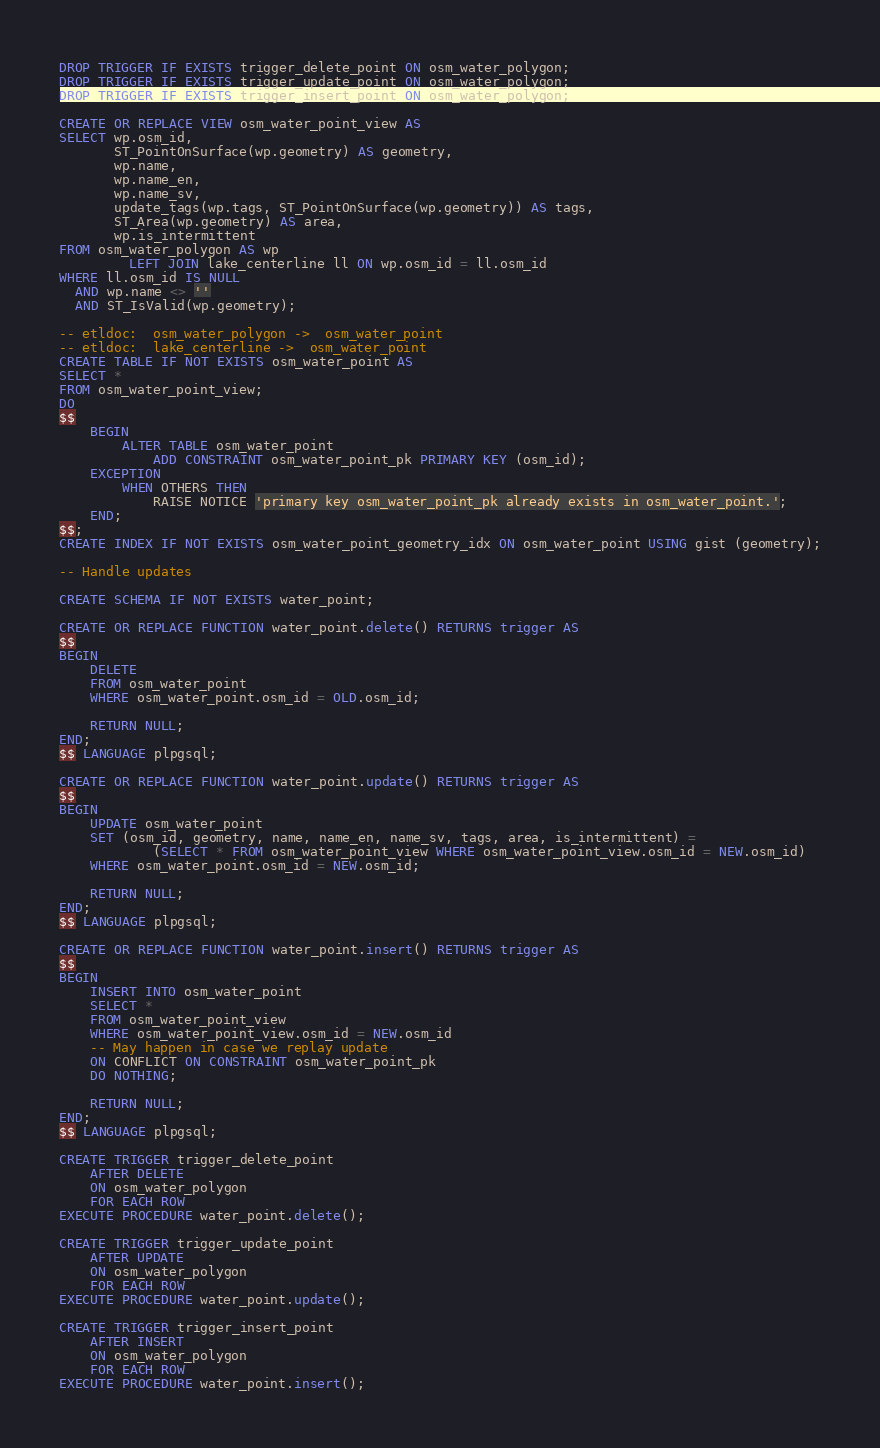<code> <loc_0><loc_0><loc_500><loc_500><_SQL_>DROP TRIGGER IF EXISTS trigger_delete_point ON osm_water_polygon;
DROP TRIGGER IF EXISTS trigger_update_point ON osm_water_polygon;
DROP TRIGGER IF EXISTS trigger_insert_point ON osm_water_polygon;

CREATE OR REPLACE VIEW osm_water_point_view AS
SELECT wp.osm_id,
       ST_PointOnSurface(wp.geometry) AS geometry,
       wp.name,
       wp.name_en,
       wp.name_sv,
       update_tags(wp.tags, ST_PointOnSurface(wp.geometry)) AS tags,
       ST_Area(wp.geometry) AS area,
       wp.is_intermittent
FROM osm_water_polygon AS wp
         LEFT JOIN lake_centerline ll ON wp.osm_id = ll.osm_id
WHERE ll.osm_id IS NULL
  AND wp.name <> ''
  AND ST_IsValid(wp.geometry);

-- etldoc:  osm_water_polygon ->  osm_water_point
-- etldoc:  lake_centerline ->  osm_water_point
CREATE TABLE IF NOT EXISTS osm_water_point AS
SELECT *
FROM osm_water_point_view;
DO
$$
    BEGIN
        ALTER TABLE osm_water_point
            ADD CONSTRAINT osm_water_point_pk PRIMARY KEY (osm_id);
    EXCEPTION
        WHEN OTHERS THEN
            RAISE NOTICE 'primary key osm_water_point_pk already exists in osm_water_point.';
    END;
$$;
CREATE INDEX IF NOT EXISTS osm_water_point_geometry_idx ON osm_water_point USING gist (geometry);

-- Handle updates

CREATE SCHEMA IF NOT EXISTS water_point;

CREATE OR REPLACE FUNCTION water_point.delete() RETURNS trigger AS
$$
BEGIN
    DELETE
    FROM osm_water_point
    WHERE osm_water_point.osm_id = OLD.osm_id;

    RETURN NULL;
END;
$$ LANGUAGE plpgsql;

CREATE OR REPLACE FUNCTION water_point.update() RETURNS trigger AS
$$
BEGIN
    UPDATE osm_water_point
    SET (osm_id, geometry, name, name_en, name_sv, tags, area, is_intermittent) =
            (SELECT * FROM osm_water_point_view WHERE osm_water_point_view.osm_id = NEW.osm_id)
    WHERE osm_water_point.osm_id = NEW.osm_id;

    RETURN NULL;
END;
$$ LANGUAGE plpgsql;

CREATE OR REPLACE FUNCTION water_point.insert() RETURNS trigger AS
$$
BEGIN
    INSERT INTO osm_water_point
    SELECT *
    FROM osm_water_point_view
    WHERE osm_water_point_view.osm_id = NEW.osm_id
    -- May happen in case we replay update
    ON CONFLICT ON CONSTRAINT osm_water_point_pk
    DO NOTHING;

    RETURN NULL;
END;
$$ LANGUAGE plpgsql;

CREATE TRIGGER trigger_delete_point
    AFTER DELETE
    ON osm_water_polygon
    FOR EACH ROW
EXECUTE PROCEDURE water_point.delete();

CREATE TRIGGER trigger_update_point
    AFTER UPDATE
    ON osm_water_polygon
    FOR EACH ROW
EXECUTE PROCEDURE water_point.update();

CREATE TRIGGER trigger_insert_point
    AFTER INSERT
    ON osm_water_polygon
    FOR EACH ROW
EXECUTE PROCEDURE water_point.insert();
</code> 